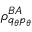Convert formula to latex. <formula><loc_0><loc_0><loc_500><loc_500>\rho _ { q _ { \theta } p _ { \theta } } ^ { B A }</formula> 